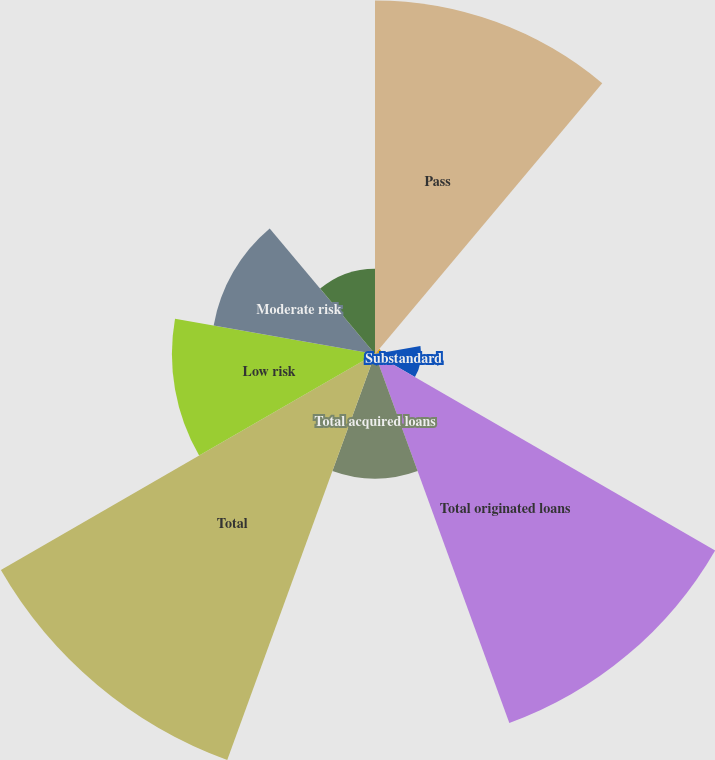Convert chart to OTSL. <chart><loc_0><loc_0><loc_500><loc_500><pie_chart><fcel>Pass<fcel>Special mention<fcel>Substandard<fcel>Total originated loans<fcel>Total acquired loans<fcel>Total<fcel>Low risk<fcel>Moderate risk<fcel>High risk<nl><fcel>19.55%<fcel>0.38%<fcel>2.55%<fcel>21.72%<fcel>6.89%<fcel>23.89%<fcel>11.23%<fcel>9.06%<fcel>4.72%<nl></chart> 